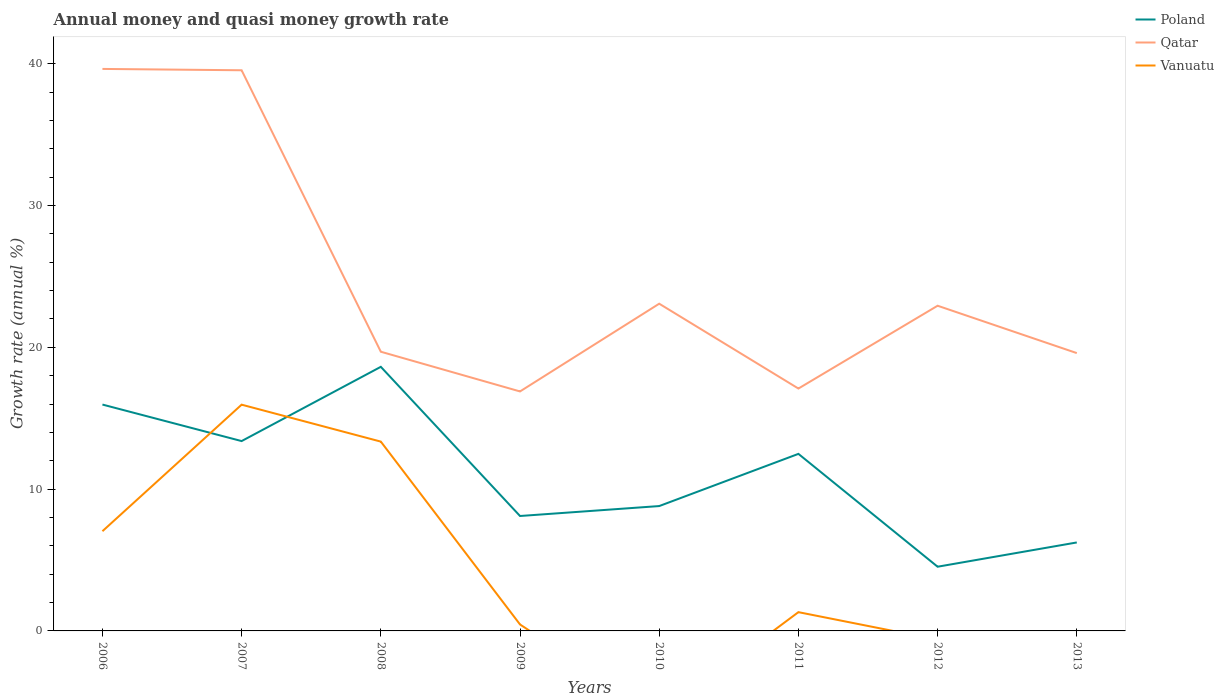How many different coloured lines are there?
Your answer should be compact. 3. Is the number of lines equal to the number of legend labels?
Your response must be concise. No. Across all years, what is the maximum growth rate in Poland?
Your answer should be compact. 4.53. What is the total growth rate in Poland in the graph?
Make the answer very short. -5.24. What is the difference between the highest and the second highest growth rate in Qatar?
Keep it short and to the point. 22.75. What is the difference between the highest and the lowest growth rate in Vanuatu?
Your response must be concise. 3. What is the difference between two consecutive major ticks on the Y-axis?
Give a very brief answer. 10. Are the values on the major ticks of Y-axis written in scientific E-notation?
Provide a short and direct response. No. Does the graph contain any zero values?
Your response must be concise. Yes. Does the graph contain grids?
Give a very brief answer. No. How many legend labels are there?
Your response must be concise. 3. How are the legend labels stacked?
Provide a short and direct response. Vertical. What is the title of the graph?
Keep it short and to the point. Annual money and quasi money growth rate. What is the label or title of the X-axis?
Offer a terse response. Years. What is the label or title of the Y-axis?
Your answer should be compact. Growth rate (annual %). What is the Growth rate (annual %) in Poland in 2006?
Provide a short and direct response. 15.96. What is the Growth rate (annual %) of Qatar in 2006?
Provide a short and direct response. 39.63. What is the Growth rate (annual %) of Vanuatu in 2006?
Keep it short and to the point. 7.03. What is the Growth rate (annual %) of Poland in 2007?
Your answer should be very brief. 13.39. What is the Growth rate (annual %) of Qatar in 2007?
Offer a very short reply. 39.54. What is the Growth rate (annual %) in Vanuatu in 2007?
Give a very brief answer. 15.96. What is the Growth rate (annual %) of Poland in 2008?
Ensure brevity in your answer.  18.63. What is the Growth rate (annual %) of Qatar in 2008?
Offer a very short reply. 19.69. What is the Growth rate (annual %) of Vanuatu in 2008?
Your answer should be very brief. 13.35. What is the Growth rate (annual %) in Poland in 2009?
Provide a succinct answer. 8.11. What is the Growth rate (annual %) of Qatar in 2009?
Offer a very short reply. 16.89. What is the Growth rate (annual %) of Vanuatu in 2009?
Your answer should be very brief. 0.46. What is the Growth rate (annual %) in Poland in 2010?
Your answer should be compact. 8.81. What is the Growth rate (annual %) of Qatar in 2010?
Offer a terse response. 23.08. What is the Growth rate (annual %) in Poland in 2011?
Provide a short and direct response. 12.49. What is the Growth rate (annual %) in Qatar in 2011?
Provide a short and direct response. 17.09. What is the Growth rate (annual %) in Vanuatu in 2011?
Your answer should be very brief. 1.32. What is the Growth rate (annual %) of Poland in 2012?
Your response must be concise. 4.53. What is the Growth rate (annual %) in Qatar in 2012?
Ensure brevity in your answer.  22.93. What is the Growth rate (annual %) of Poland in 2013?
Provide a succinct answer. 6.24. What is the Growth rate (annual %) of Qatar in 2013?
Keep it short and to the point. 19.59. Across all years, what is the maximum Growth rate (annual %) of Poland?
Offer a terse response. 18.63. Across all years, what is the maximum Growth rate (annual %) of Qatar?
Provide a short and direct response. 39.63. Across all years, what is the maximum Growth rate (annual %) of Vanuatu?
Make the answer very short. 15.96. Across all years, what is the minimum Growth rate (annual %) in Poland?
Ensure brevity in your answer.  4.53. Across all years, what is the minimum Growth rate (annual %) in Qatar?
Offer a terse response. 16.89. Across all years, what is the minimum Growth rate (annual %) in Vanuatu?
Make the answer very short. 0. What is the total Growth rate (annual %) in Poland in the graph?
Provide a short and direct response. 88.14. What is the total Growth rate (annual %) in Qatar in the graph?
Your answer should be compact. 198.45. What is the total Growth rate (annual %) of Vanuatu in the graph?
Keep it short and to the point. 38.12. What is the difference between the Growth rate (annual %) in Poland in 2006 and that in 2007?
Your response must be concise. 2.58. What is the difference between the Growth rate (annual %) of Qatar in 2006 and that in 2007?
Ensure brevity in your answer.  0.09. What is the difference between the Growth rate (annual %) of Vanuatu in 2006 and that in 2007?
Provide a short and direct response. -8.92. What is the difference between the Growth rate (annual %) in Poland in 2006 and that in 2008?
Make the answer very short. -2.66. What is the difference between the Growth rate (annual %) of Qatar in 2006 and that in 2008?
Your response must be concise. 19.94. What is the difference between the Growth rate (annual %) in Vanuatu in 2006 and that in 2008?
Your response must be concise. -6.32. What is the difference between the Growth rate (annual %) in Poland in 2006 and that in 2009?
Keep it short and to the point. 7.86. What is the difference between the Growth rate (annual %) in Qatar in 2006 and that in 2009?
Offer a terse response. 22.75. What is the difference between the Growth rate (annual %) of Vanuatu in 2006 and that in 2009?
Offer a very short reply. 6.58. What is the difference between the Growth rate (annual %) of Poland in 2006 and that in 2010?
Your answer should be very brief. 7.16. What is the difference between the Growth rate (annual %) of Qatar in 2006 and that in 2010?
Provide a succinct answer. 16.56. What is the difference between the Growth rate (annual %) of Poland in 2006 and that in 2011?
Offer a very short reply. 3.48. What is the difference between the Growth rate (annual %) of Qatar in 2006 and that in 2011?
Ensure brevity in your answer.  22.54. What is the difference between the Growth rate (annual %) of Vanuatu in 2006 and that in 2011?
Offer a very short reply. 5.71. What is the difference between the Growth rate (annual %) in Poland in 2006 and that in 2012?
Your response must be concise. 11.44. What is the difference between the Growth rate (annual %) of Qatar in 2006 and that in 2012?
Your answer should be compact. 16.7. What is the difference between the Growth rate (annual %) of Poland in 2006 and that in 2013?
Make the answer very short. 9.72. What is the difference between the Growth rate (annual %) of Qatar in 2006 and that in 2013?
Give a very brief answer. 20.04. What is the difference between the Growth rate (annual %) in Poland in 2007 and that in 2008?
Provide a short and direct response. -5.24. What is the difference between the Growth rate (annual %) in Qatar in 2007 and that in 2008?
Your answer should be very brief. 19.85. What is the difference between the Growth rate (annual %) of Vanuatu in 2007 and that in 2008?
Your response must be concise. 2.61. What is the difference between the Growth rate (annual %) in Poland in 2007 and that in 2009?
Keep it short and to the point. 5.28. What is the difference between the Growth rate (annual %) in Qatar in 2007 and that in 2009?
Your response must be concise. 22.65. What is the difference between the Growth rate (annual %) in Vanuatu in 2007 and that in 2009?
Make the answer very short. 15.5. What is the difference between the Growth rate (annual %) in Poland in 2007 and that in 2010?
Keep it short and to the point. 4.58. What is the difference between the Growth rate (annual %) of Qatar in 2007 and that in 2010?
Provide a succinct answer. 16.46. What is the difference between the Growth rate (annual %) in Poland in 2007 and that in 2011?
Your answer should be very brief. 0.9. What is the difference between the Growth rate (annual %) in Qatar in 2007 and that in 2011?
Keep it short and to the point. 22.45. What is the difference between the Growth rate (annual %) of Vanuatu in 2007 and that in 2011?
Your answer should be compact. 14.63. What is the difference between the Growth rate (annual %) of Poland in 2007 and that in 2012?
Keep it short and to the point. 8.86. What is the difference between the Growth rate (annual %) of Qatar in 2007 and that in 2012?
Provide a short and direct response. 16.61. What is the difference between the Growth rate (annual %) of Poland in 2007 and that in 2013?
Keep it short and to the point. 7.15. What is the difference between the Growth rate (annual %) in Qatar in 2007 and that in 2013?
Give a very brief answer. 19.95. What is the difference between the Growth rate (annual %) in Poland in 2008 and that in 2009?
Provide a short and direct response. 10.52. What is the difference between the Growth rate (annual %) of Qatar in 2008 and that in 2009?
Give a very brief answer. 2.8. What is the difference between the Growth rate (annual %) in Vanuatu in 2008 and that in 2009?
Provide a succinct answer. 12.9. What is the difference between the Growth rate (annual %) in Poland in 2008 and that in 2010?
Your answer should be very brief. 9.82. What is the difference between the Growth rate (annual %) of Qatar in 2008 and that in 2010?
Provide a short and direct response. -3.39. What is the difference between the Growth rate (annual %) in Poland in 2008 and that in 2011?
Ensure brevity in your answer.  6.14. What is the difference between the Growth rate (annual %) of Qatar in 2008 and that in 2011?
Provide a succinct answer. 2.6. What is the difference between the Growth rate (annual %) in Vanuatu in 2008 and that in 2011?
Ensure brevity in your answer.  12.03. What is the difference between the Growth rate (annual %) of Poland in 2008 and that in 2012?
Provide a short and direct response. 14.1. What is the difference between the Growth rate (annual %) of Qatar in 2008 and that in 2012?
Your answer should be compact. -3.24. What is the difference between the Growth rate (annual %) of Poland in 2008 and that in 2013?
Your response must be concise. 12.39. What is the difference between the Growth rate (annual %) of Qatar in 2008 and that in 2013?
Offer a terse response. 0.1. What is the difference between the Growth rate (annual %) in Poland in 2009 and that in 2010?
Keep it short and to the point. -0.7. What is the difference between the Growth rate (annual %) of Qatar in 2009 and that in 2010?
Provide a succinct answer. -6.19. What is the difference between the Growth rate (annual %) of Poland in 2009 and that in 2011?
Offer a terse response. -4.38. What is the difference between the Growth rate (annual %) in Qatar in 2009 and that in 2011?
Ensure brevity in your answer.  -0.2. What is the difference between the Growth rate (annual %) of Vanuatu in 2009 and that in 2011?
Give a very brief answer. -0.87. What is the difference between the Growth rate (annual %) of Poland in 2009 and that in 2012?
Offer a very short reply. 3.58. What is the difference between the Growth rate (annual %) in Qatar in 2009 and that in 2012?
Keep it short and to the point. -6.04. What is the difference between the Growth rate (annual %) of Poland in 2009 and that in 2013?
Offer a terse response. 1.87. What is the difference between the Growth rate (annual %) of Qatar in 2009 and that in 2013?
Give a very brief answer. -2.7. What is the difference between the Growth rate (annual %) in Poland in 2010 and that in 2011?
Provide a succinct answer. -3.68. What is the difference between the Growth rate (annual %) in Qatar in 2010 and that in 2011?
Your response must be concise. 5.98. What is the difference between the Growth rate (annual %) of Poland in 2010 and that in 2012?
Keep it short and to the point. 4.28. What is the difference between the Growth rate (annual %) in Qatar in 2010 and that in 2012?
Provide a succinct answer. 0.14. What is the difference between the Growth rate (annual %) in Poland in 2010 and that in 2013?
Provide a succinct answer. 2.57. What is the difference between the Growth rate (annual %) of Qatar in 2010 and that in 2013?
Ensure brevity in your answer.  3.48. What is the difference between the Growth rate (annual %) in Poland in 2011 and that in 2012?
Provide a succinct answer. 7.96. What is the difference between the Growth rate (annual %) in Qatar in 2011 and that in 2012?
Offer a very short reply. -5.84. What is the difference between the Growth rate (annual %) of Poland in 2011 and that in 2013?
Your answer should be very brief. 6.25. What is the difference between the Growth rate (annual %) of Qatar in 2011 and that in 2013?
Make the answer very short. -2.5. What is the difference between the Growth rate (annual %) of Poland in 2012 and that in 2013?
Your response must be concise. -1.71. What is the difference between the Growth rate (annual %) of Qatar in 2012 and that in 2013?
Provide a succinct answer. 3.34. What is the difference between the Growth rate (annual %) of Poland in 2006 and the Growth rate (annual %) of Qatar in 2007?
Offer a very short reply. -23.58. What is the difference between the Growth rate (annual %) of Poland in 2006 and the Growth rate (annual %) of Vanuatu in 2007?
Your answer should be very brief. 0.01. What is the difference between the Growth rate (annual %) in Qatar in 2006 and the Growth rate (annual %) in Vanuatu in 2007?
Your response must be concise. 23.68. What is the difference between the Growth rate (annual %) of Poland in 2006 and the Growth rate (annual %) of Qatar in 2008?
Offer a terse response. -3.73. What is the difference between the Growth rate (annual %) in Poland in 2006 and the Growth rate (annual %) in Vanuatu in 2008?
Make the answer very short. 2.61. What is the difference between the Growth rate (annual %) in Qatar in 2006 and the Growth rate (annual %) in Vanuatu in 2008?
Ensure brevity in your answer.  26.28. What is the difference between the Growth rate (annual %) of Poland in 2006 and the Growth rate (annual %) of Qatar in 2009?
Your response must be concise. -0.92. What is the difference between the Growth rate (annual %) in Poland in 2006 and the Growth rate (annual %) in Vanuatu in 2009?
Offer a terse response. 15.51. What is the difference between the Growth rate (annual %) in Qatar in 2006 and the Growth rate (annual %) in Vanuatu in 2009?
Offer a very short reply. 39.18. What is the difference between the Growth rate (annual %) in Poland in 2006 and the Growth rate (annual %) in Qatar in 2010?
Provide a succinct answer. -7.11. What is the difference between the Growth rate (annual %) in Poland in 2006 and the Growth rate (annual %) in Qatar in 2011?
Your response must be concise. -1.13. What is the difference between the Growth rate (annual %) in Poland in 2006 and the Growth rate (annual %) in Vanuatu in 2011?
Provide a short and direct response. 14.64. What is the difference between the Growth rate (annual %) in Qatar in 2006 and the Growth rate (annual %) in Vanuatu in 2011?
Give a very brief answer. 38.31. What is the difference between the Growth rate (annual %) in Poland in 2006 and the Growth rate (annual %) in Qatar in 2012?
Offer a very short reply. -6.97. What is the difference between the Growth rate (annual %) in Poland in 2006 and the Growth rate (annual %) in Qatar in 2013?
Keep it short and to the point. -3.63. What is the difference between the Growth rate (annual %) of Poland in 2007 and the Growth rate (annual %) of Qatar in 2008?
Keep it short and to the point. -6.3. What is the difference between the Growth rate (annual %) of Poland in 2007 and the Growth rate (annual %) of Vanuatu in 2008?
Your answer should be compact. 0.04. What is the difference between the Growth rate (annual %) of Qatar in 2007 and the Growth rate (annual %) of Vanuatu in 2008?
Keep it short and to the point. 26.19. What is the difference between the Growth rate (annual %) of Poland in 2007 and the Growth rate (annual %) of Qatar in 2009?
Provide a short and direct response. -3.5. What is the difference between the Growth rate (annual %) of Poland in 2007 and the Growth rate (annual %) of Vanuatu in 2009?
Make the answer very short. 12.93. What is the difference between the Growth rate (annual %) in Qatar in 2007 and the Growth rate (annual %) in Vanuatu in 2009?
Ensure brevity in your answer.  39.08. What is the difference between the Growth rate (annual %) of Poland in 2007 and the Growth rate (annual %) of Qatar in 2010?
Ensure brevity in your answer.  -9.69. What is the difference between the Growth rate (annual %) of Poland in 2007 and the Growth rate (annual %) of Qatar in 2011?
Your answer should be very brief. -3.7. What is the difference between the Growth rate (annual %) in Poland in 2007 and the Growth rate (annual %) in Vanuatu in 2011?
Provide a succinct answer. 12.07. What is the difference between the Growth rate (annual %) of Qatar in 2007 and the Growth rate (annual %) of Vanuatu in 2011?
Provide a succinct answer. 38.22. What is the difference between the Growth rate (annual %) in Poland in 2007 and the Growth rate (annual %) in Qatar in 2012?
Keep it short and to the point. -9.55. What is the difference between the Growth rate (annual %) of Poland in 2007 and the Growth rate (annual %) of Qatar in 2013?
Your response must be concise. -6.2. What is the difference between the Growth rate (annual %) of Poland in 2008 and the Growth rate (annual %) of Qatar in 2009?
Provide a succinct answer. 1.74. What is the difference between the Growth rate (annual %) of Poland in 2008 and the Growth rate (annual %) of Vanuatu in 2009?
Provide a succinct answer. 18.17. What is the difference between the Growth rate (annual %) in Qatar in 2008 and the Growth rate (annual %) in Vanuatu in 2009?
Make the answer very short. 19.23. What is the difference between the Growth rate (annual %) of Poland in 2008 and the Growth rate (annual %) of Qatar in 2010?
Ensure brevity in your answer.  -4.45. What is the difference between the Growth rate (annual %) in Poland in 2008 and the Growth rate (annual %) in Qatar in 2011?
Give a very brief answer. 1.53. What is the difference between the Growth rate (annual %) of Poland in 2008 and the Growth rate (annual %) of Vanuatu in 2011?
Give a very brief answer. 17.3. What is the difference between the Growth rate (annual %) of Qatar in 2008 and the Growth rate (annual %) of Vanuatu in 2011?
Provide a short and direct response. 18.37. What is the difference between the Growth rate (annual %) in Poland in 2008 and the Growth rate (annual %) in Qatar in 2012?
Ensure brevity in your answer.  -4.31. What is the difference between the Growth rate (annual %) of Poland in 2008 and the Growth rate (annual %) of Qatar in 2013?
Ensure brevity in your answer.  -0.97. What is the difference between the Growth rate (annual %) in Poland in 2009 and the Growth rate (annual %) in Qatar in 2010?
Provide a short and direct response. -14.97. What is the difference between the Growth rate (annual %) of Poland in 2009 and the Growth rate (annual %) of Qatar in 2011?
Your answer should be compact. -8.99. What is the difference between the Growth rate (annual %) in Poland in 2009 and the Growth rate (annual %) in Vanuatu in 2011?
Your answer should be compact. 6.78. What is the difference between the Growth rate (annual %) of Qatar in 2009 and the Growth rate (annual %) of Vanuatu in 2011?
Offer a very short reply. 15.57. What is the difference between the Growth rate (annual %) of Poland in 2009 and the Growth rate (annual %) of Qatar in 2012?
Your response must be concise. -14.83. What is the difference between the Growth rate (annual %) in Poland in 2009 and the Growth rate (annual %) in Qatar in 2013?
Make the answer very short. -11.49. What is the difference between the Growth rate (annual %) of Poland in 2010 and the Growth rate (annual %) of Qatar in 2011?
Your answer should be very brief. -8.29. What is the difference between the Growth rate (annual %) in Poland in 2010 and the Growth rate (annual %) in Vanuatu in 2011?
Your answer should be compact. 7.48. What is the difference between the Growth rate (annual %) in Qatar in 2010 and the Growth rate (annual %) in Vanuatu in 2011?
Give a very brief answer. 21.75. What is the difference between the Growth rate (annual %) in Poland in 2010 and the Growth rate (annual %) in Qatar in 2012?
Your answer should be very brief. -14.13. What is the difference between the Growth rate (annual %) of Poland in 2010 and the Growth rate (annual %) of Qatar in 2013?
Provide a short and direct response. -10.79. What is the difference between the Growth rate (annual %) of Poland in 2011 and the Growth rate (annual %) of Qatar in 2012?
Your response must be concise. -10.45. What is the difference between the Growth rate (annual %) in Poland in 2011 and the Growth rate (annual %) in Qatar in 2013?
Make the answer very short. -7.11. What is the difference between the Growth rate (annual %) in Poland in 2012 and the Growth rate (annual %) in Qatar in 2013?
Offer a very short reply. -15.07. What is the average Growth rate (annual %) of Poland per year?
Offer a very short reply. 11.02. What is the average Growth rate (annual %) in Qatar per year?
Give a very brief answer. 24.81. What is the average Growth rate (annual %) of Vanuatu per year?
Offer a very short reply. 4.77. In the year 2006, what is the difference between the Growth rate (annual %) of Poland and Growth rate (annual %) of Qatar?
Offer a very short reply. -23.67. In the year 2006, what is the difference between the Growth rate (annual %) in Poland and Growth rate (annual %) in Vanuatu?
Provide a succinct answer. 8.93. In the year 2006, what is the difference between the Growth rate (annual %) of Qatar and Growth rate (annual %) of Vanuatu?
Your answer should be compact. 32.6. In the year 2007, what is the difference between the Growth rate (annual %) in Poland and Growth rate (annual %) in Qatar?
Offer a terse response. -26.15. In the year 2007, what is the difference between the Growth rate (annual %) in Poland and Growth rate (annual %) in Vanuatu?
Provide a short and direct response. -2.57. In the year 2007, what is the difference between the Growth rate (annual %) of Qatar and Growth rate (annual %) of Vanuatu?
Offer a very short reply. 23.58. In the year 2008, what is the difference between the Growth rate (annual %) of Poland and Growth rate (annual %) of Qatar?
Your answer should be very brief. -1.06. In the year 2008, what is the difference between the Growth rate (annual %) in Poland and Growth rate (annual %) in Vanuatu?
Ensure brevity in your answer.  5.27. In the year 2008, what is the difference between the Growth rate (annual %) of Qatar and Growth rate (annual %) of Vanuatu?
Offer a very short reply. 6.34. In the year 2009, what is the difference between the Growth rate (annual %) in Poland and Growth rate (annual %) in Qatar?
Your answer should be compact. -8.78. In the year 2009, what is the difference between the Growth rate (annual %) of Poland and Growth rate (annual %) of Vanuatu?
Offer a terse response. 7.65. In the year 2009, what is the difference between the Growth rate (annual %) in Qatar and Growth rate (annual %) in Vanuatu?
Offer a terse response. 16.43. In the year 2010, what is the difference between the Growth rate (annual %) in Poland and Growth rate (annual %) in Qatar?
Ensure brevity in your answer.  -14.27. In the year 2011, what is the difference between the Growth rate (annual %) in Poland and Growth rate (annual %) in Qatar?
Provide a succinct answer. -4.61. In the year 2011, what is the difference between the Growth rate (annual %) of Poland and Growth rate (annual %) of Vanuatu?
Your answer should be very brief. 11.16. In the year 2011, what is the difference between the Growth rate (annual %) of Qatar and Growth rate (annual %) of Vanuatu?
Give a very brief answer. 15.77. In the year 2012, what is the difference between the Growth rate (annual %) of Poland and Growth rate (annual %) of Qatar?
Offer a terse response. -18.41. In the year 2013, what is the difference between the Growth rate (annual %) in Poland and Growth rate (annual %) in Qatar?
Offer a terse response. -13.35. What is the ratio of the Growth rate (annual %) of Poland in 2006 to that in 2007?
Your answer should be compact. 1.19. What is the ratio of the Growth rate (annual %) of Qatar in 2006 to that in 2007?
Make the answer very short. 1. What is the ratio of the Growth rate (annual %) in Vanuatu in 2006 to that in 2007?
Your answer should be compact. 0.44. What is the ratio of the Growth rate (annual %) of Poland in 2006 to that in 2008?
Your answer should be very brief. 0.86. What is the ratio of the Growth rate (annual %) in Qatar in 2006 to that in 2008?
Offer a terse response. 2.01. What is the ratio of the Growth rate (annual %) of Vanuatu in 2006 to that in 2008?
Give a very brief answer. 0.53. What is the ratio of the Growth rate (annual %) of Poland in 2006 to that in 2009?
Provide a short and direct response. 1.97. What is the ratio of the Growth rate (annual %) in Qatar in 2006 to that in 2009?
Your response must be concise. 2.35. What is the ratio of the Growth rate (annual %) of Vanuatu in 2006 to that in 2009?
Provide a succinct answer. 15.42. What is the ratio of the Growth rate (annual %) of Poland in 2006 to that in 2010?
Keep it short and to the point. 1.81. What is the ratio of the Growth rate (annual %) in Qatar in 2006 to that in 2010?
Your response must be concise. 1.72. What is the ratio of the Growth rate (annual %) of Poland in 2006 to that in 2011?
Ensure brevity in your answer.  1.28. What is the ratio of the Growth rate (annual %) in Qatar in 2006 to that in 2011?
Your response must be concise. 2.32. What is the ratio of the Growth rate (annual %) of Vanuatu in 2006 to that in 2011?
Make the answer very short. 5.31. What is the ratio of the Growth rate (annual %) in Poland in 2006 to that in 2012?
Your response must be concise. 3.53. What is the ratio of the Growth rate (annual %) in Qatar in 2006 to that in 2012?
Your answer should be compact. 1.73. What is the ratio of the Growth rate (annual %) in Poland in 2006 to that in 2013?
Make the answer very short. 2.56. What is the ratio of the Growth rate (annual %) in Qatar in 2006 to that in 2013?
Offer a terse response. 2.02. What is the ratio of the Growth rate (annual %) in Poland in 2007 to that in 2008?
Keep it short and to the point. 0.72. What is the ratio of the Growth rate (annual %) in Qatar in 2007 to that in 2008?
Offer a very short reply. 2.01. What is the ratio of the Growth rate (annual %) in Vanuatu in 2007 to that in 2008?
Make the answer very short. 1.2. What is the ratio of the Growth rate (annual %) of Poland in 2007 to that in 2009?
Make the answer very short. 1.65. What is the ratio of the Growth rate (annual %) in Qatar in 2007 to that in 2009?
Your response must be concise. 2.34. What is the ratio of the Growth rate (annual %) in Vanuatu in 2007 to that in 2009?
Your answer should be compact. 34.99. What is the ratio of the Growth rate (annual %) of Poland in 2007 to that in 2010?
Keep it short and to the point. 1.52. What is the ratio of the Growth rate (annual %) of Qatar in 2007 to that in 2010?
Provide a succinct answer. 1.71. What is the ratio of the Growth rate (annual %) in Poland in 2007 to that in 2011?
Provide a short and direct response. 1.07. What is the ratio of the Growth rate (annual %) in Qatar in 2007 to that in 2011?
Your response must be concise. 2.31. What is the ratio of the Growth rate (annual %) in Vanuatu in 2007 to that in 2011?
Offer a terse response. 12.06. What is the ratio of the Growth rate (annual %) in Poland in 2007 to that in 2012?
Offer a very short reply. 2.96. What is the ratio of the Growth rate (annual %) of Qatar in 2007 to that in 2012?
Provide a succinct answer. 1.72. What is the ratio of the Growth rate (annual %) in Poland in 2007 to that in 2013?
Offer a very short reply. 2.15. What is the ratio of the Growth rate (annual %) in Qatar in 2007 to that in 2013?
Keep it short and to the point. 2.02. What is the ratio of the Growth rate (annual %) in Poland in 2008 to that in 2009?
Make the answer very short. 2.3. What is the ratio of the Growth rate (annual %) in Qatar in 2008 to that in 2009?
Make the answer very short. 1.17. What is the ratio of the Growth rate (annual %) of Vanuatu in 2008 to that in 2009?
Make the answer very short. 29.27. What is the ratio of the Growth rate (annual %) in Poland in 2008 to that in 2010?
Make the answer very short. 2.12. What is the ratio of the Growth rate (annual %) of Qatar in 2008 to that in 2010?
Your answer should be very brief. 0.85. What is the ratio of the Growth rate (annual %) of Poland in 2008 to that in 2011?
Keep it short and to the point. 1.49. What is the ratio of the Growth rate (annual %) of Qatar in 2008 to that in 2011?
Keep it short and to the point. 1.15. What is the ratio of the Growth rate (annual %) of Vanuatu in 2008 to that in 2011?
Offer a terse response. 10.09. What is the ratio of the Growth rate (annual %) in Poland in 2008 to that in 2012?
Offer a terse response. 4.11. What is the ratio of the Growth rate (annual %) in Qatar in 2008 to that in 2012?
Your answer should be compact. 0.86. What is the ratio of the Growth rate (annual %) of Poland in 2008 to that in 2013?
Your answer should be very brief. 2.99. What is the ratio of the Growth rate (annual %) of Qatar in 2008 to that in 2013?
Make the answer very short. 1. What is the ratio of the Growth rate (annual %) in Poland in 2009 to that in 2010?
Your answer should be compact. 0.92. What is the ratio of the Growth rate (annual %) in Qatar in 2009 to that in 2010?
Make the answer very short. 0.73. What is the ratio of the Growth rate (annual %) in Poland in 2009 to that in 2011?
Offer a terse response. 0.65. What is the ratio of the Growth rate (annual %) in Qatar in 2009 to that in 2011?
Provide a succinct answer. 0.99. What is the ratio of the Growth rate (annual %) in Vanuatu in 2009 to that in 2011?
Offer a terse response. 0.34. What is the ratio of the Growth rate (annual %) in Poland in 2009 to that in 2012?
Your answer should be compact. 1.79. What is the ratio of the Growth rate (annual %) in Qatar in 2009 to that in 2012?
Your response must be concise. 0.74. What is the ratio of the Growth rate (annual %) of Poland in 2009 to that in 2013?
Ensure brevity in your answer.  1.3. What is the ratio of the Growth rate (annual %) of Qatar in 2009 to that in 2013?
Keep it short and to the point. 0.86. What is the ratio of the Growth rate (annual %) in Poland in 2010 to that in 2011?
Provide a succinct answer. 0.71. What is the ratio of the Growth rate (annual %) in Qatar in 2010 to that in 2011?
Give a very brief answer. 1.35. What is the ratio of the Growth rate (annual %) in Poland in 2010 to that in 2012?
Provide a succinct answer. 1.94. What is the ratio of the Growth rate (annual %) of Poland in 2010 to that in 2013?
Your response must be concise. 1.41. What is the ratio of the Growth rate (annual %) in Qatar in 2010 to that in 2013?
Keep it short and to the point. 1.18. What is the ratio of the Growth rate (annual %) in Poland in 2011 to that in 2012?
Give a very brief answer. 2.76. What is the ratio of the Growth rate (annual %) of Qatar in 2011 to that in 2012?
Provide a short and direct response. 0.75. What is the ratio of the Growth rate (annual %) in Poland in 2011 to that in 2013?
Your response must be concise. 2. What is the ratio of the Growth rate (annual %) in Qatar in 2011 to that in 2013?
Your response must be concise. 0.87. What is the ratio of the Growth rate (annual %) in Poland in 2012 to that in 2013?
Your answer should be very brief. 0.73. What is the ratio of the Growth rate (annual %) in Qatar in 2012 to that in 2013?
Make the answer very short. 1.17. What is the difference between the highest and the second highest Growth rate (annual %) in Poland?
Provide a short and direct response. 2.66. What is the difference between the highest and the second highest Growth rate (annual %) of Qatar?
Give a very brief answer. 0.09. What is the difference between the highest and the second highest Growth rate (annual %) in Vanuatu?
Your answer should be very brief. 2.61. What is the difference between the highest and the lowest Growth rate (annual %) of Poland?
Ensure brevity in your answer.  14.1. What is the difference between the highest and the lowest Growth rate (annual %) in Qatar?
Offer a terse response. 22.75. What is the difference between the highest and the lowest Growth rate (annual %) of Vanuatu?
Offer a terse response. 15.96. 